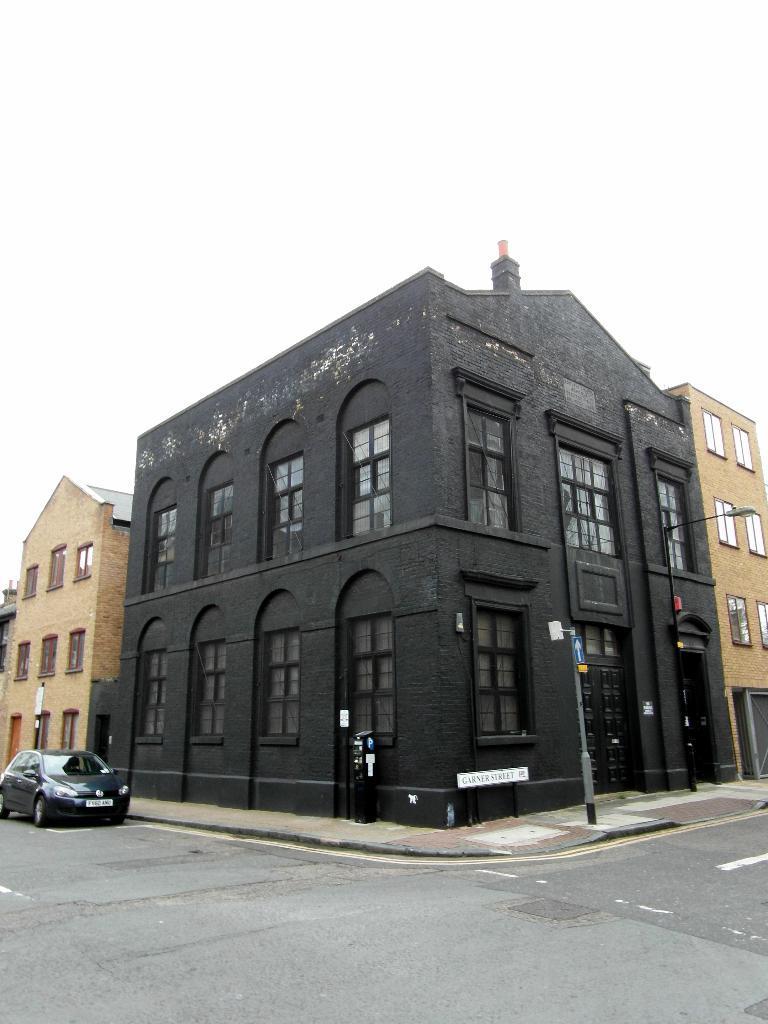How would you summarize this image in a sentence or two? In this center of the image we can see a group of buildings with windows and doors. To the left side, we can see a car parked on the road. To the right side, we can see a pole on the path. In the background, we can see the sky. 